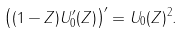<formula> <loc_0><loc_0><loc_500><loc_500>\left ( ( 1 - Z ) U _ { 0 } ^ { \prime } ( Z ) \right ) ^ { \prime } = U _ { 0 } ( Z ) ^ { 2 } .</formula> 